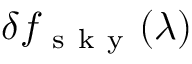<formula> <loc_0><loc_0><loc_500><loc_500>\delta f _ { s k y } ( \lambda )</formula> 